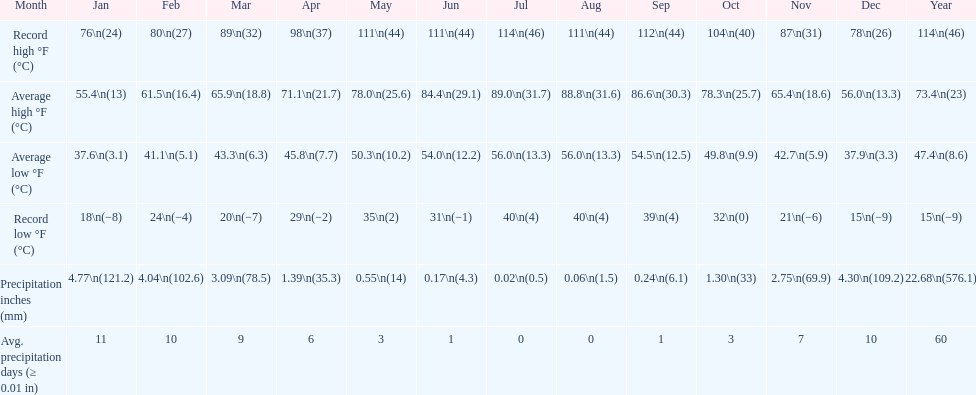How many months how a record low below 25 degrees? 6. 